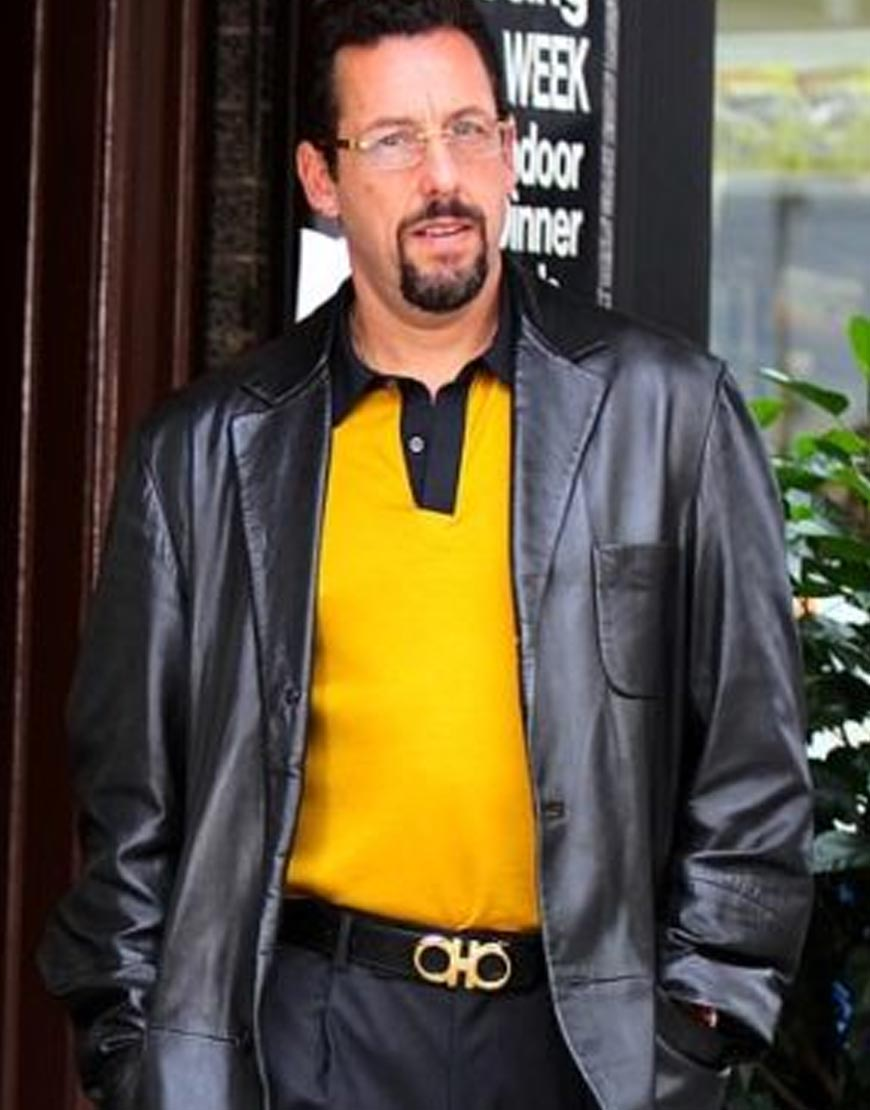What time of day could it be, given the lighting and shadows visible in the photograph? Based on the lighting and shadows within the photograph, it seems to be daytime. The natural light is soft and illuminates the man's front side, casting a faint shadow behind him to the left. This suggests that the primary light source, likely the sun, is in front of him, possibly indicating it is midday or early afternoon when the sun is higher in the sky. However, without clear indicators showing the precise position of the sun or additional shadows, it is not possible to determine the exact time of day with certainty. 